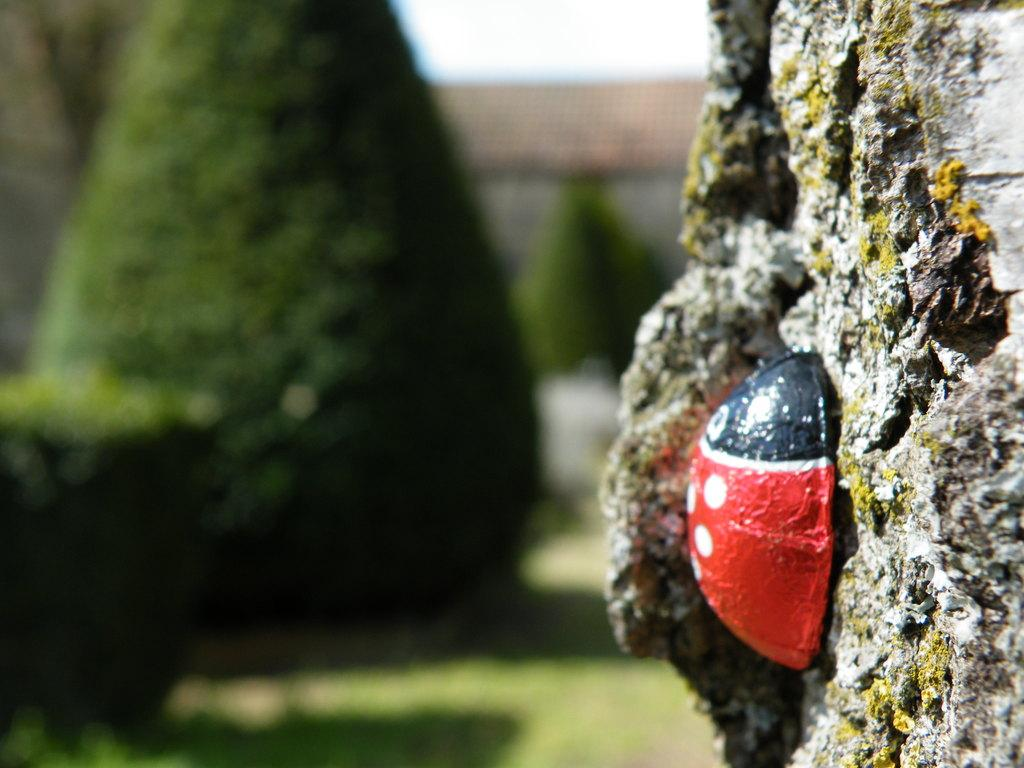What is attached to the wall in the image? The fact does not specify what the object is, but it states that there is an object attached to the wall. How is the background of the image depicted? The background of the image is blurred. What type of vegetation can be seen in the background of the image? Trees are visible in the background of the image. What type of pencil is on the shelf in the image? There is no shelf or pencil present in the image. What flavor of pie is being served in the image? There is no pie present in the image. 